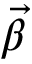<formula> <loc_0><loc_0><loc_500><loc_500>\ V e c { \beta }</formula> 